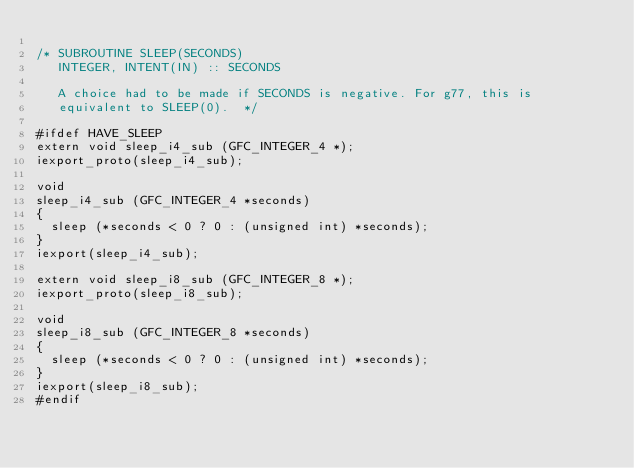<code> <loc_0><loc_0><loc_500><loc_500><_C_>
/* SUBROUTINE SLEEP(SECONDS)
   INTEGER, INTENT(IN) :: SECONDS
   
   A choice had to be made if SECONDS is negative. For g77, this is
   equivalent to SLEEP(0).  */

#ifdef HAVE_SLEEP
extern void sleep_i4_sub (GFC_INTEGER_4 *);
iexport_proto(sleep_i4_sub);

void
sleep_i4_sub (GFC_INTEGER_4 *seconds)
{
  sleep (*seconds < 0 ? 0 : (unsigned int) *seconds);
}
iexport(sleep_i4_sub);

extern void sleep_i8_sub (GFC_INTEGER_8 *);
iexport_proto(sleep_i8_sub);

void
sleep_i8_sub (GFC_INTEGER_8 *seconds)
{
  sleep (*seconds < 0 ? 0 : (unsigned int) *seconds);
}
iexport(sleep_i8_sub);
#endif
</code> 